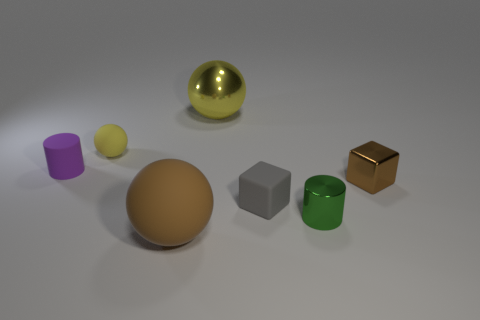Is there any other thing that is the same size as the green shiny cylinder?
Make the answer very short. Yes. What size is the purple cylinder left of the tiny thing behind the small purple rubber thing?
Keep it short and to the point. Small. What material is the yellow object that is the same size as the metal cube?
Offer a terse response. Rubber. Are there any tiny cubes that have the same material as the tiny yellow object?
Make the answer very short. Yes. There is a matte object that is to the right of the rubber ball in front of the tiny cylinder on the left side of the large rubber thing; what color is it?
Offer a very short reply. Gray. There is a tiny cylinder that is left of the tiny green object; does it have the same color as the cube that is to the left of the small green object?
Give a very brief answer. No. Are there any other things that have the same color as the large matte object?
Offer a terse response. Yes. Is the number of big balls in front of the large yellow metal sphere less than the number of large gray metallic blocks?
Give a very brief answer. No. What number of tiny brown cubes are there?
Offer a terse response. 1. Does the small green shiny object have the same shape as the big thing that is behind the shiny cylinder?
Keep it short and to the point. No. 